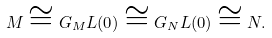<formula> <loc_0><loc_0><loc_500><loc_500>M \cong G _ { M } L ( 0 ) \cong G _ { N } L ( 0 ) \cong N .</formula> 